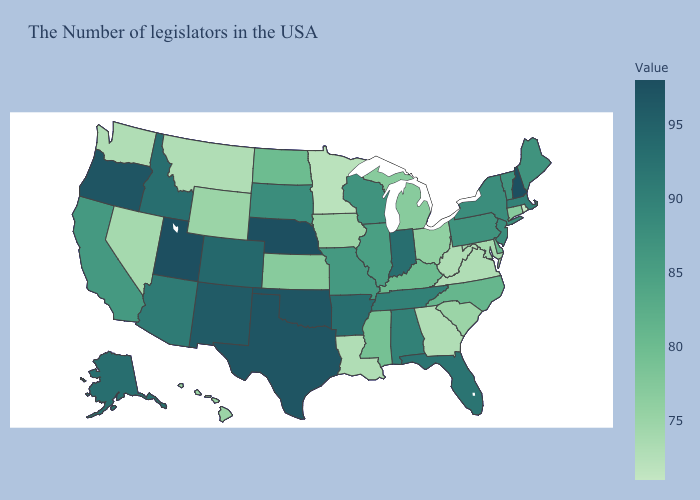Which states have the lowest value in the Northeast?
Short answer required. Rhode Island. Among the states that border West Virginia , does Pennsylvania have the highest value?
Be succinct. Yes. 